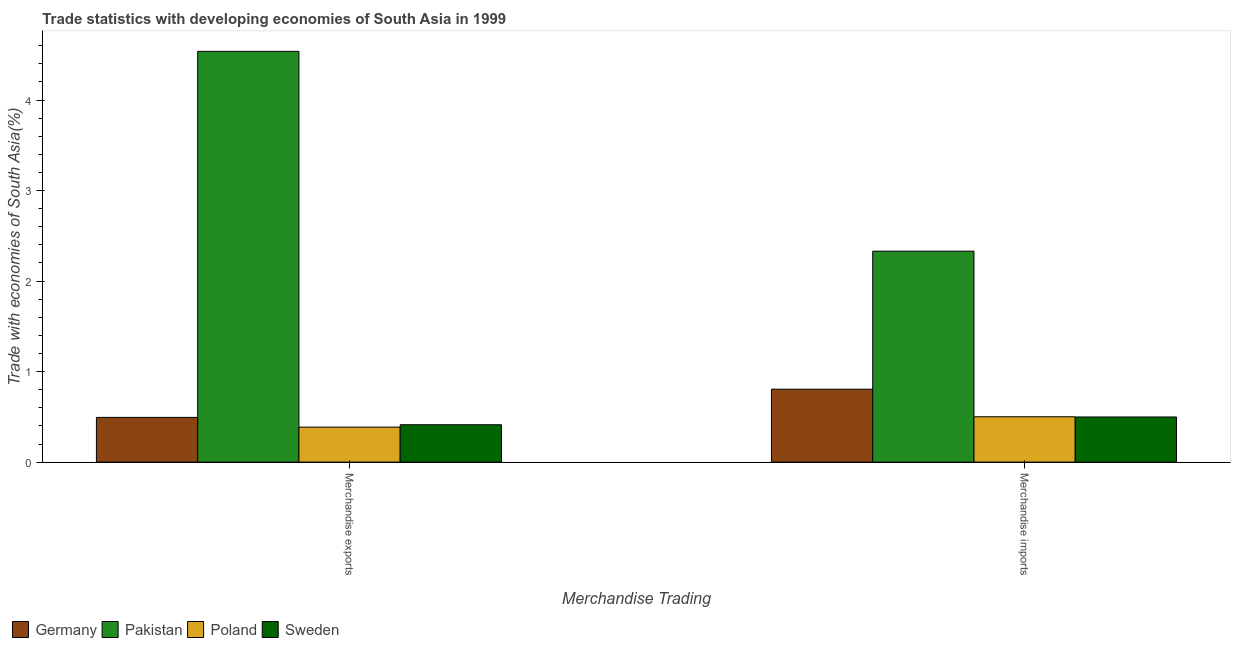How many different coloured bars are there?
Give a very brief answer. 4. Are the number of bars per tick equal to the number of legend labels?
Your response must be concise. Yes. How many bars are there on the 1st tick from the left?
Provide a short and direct response. 4. How many bars are there on the 1st tick from the right?
Keep it short and to the point. 4. What is the merchandise imports in Germany?
Give a very brief answer. 0.81. Across all countries, what is the maximum merchandise imports?
Your answer should be very brief. 2.33. Across all countries, what is the minimum merchandise imports?
Your answer should be very brief. 0.5. What is the total merchandise exports in the graph?
Your response must be concise. 5.83. What is the difference between the merchandise imports in Sweden and that in Germany?
Give a very brief answer. -0.31. What is the difference between the merchandise imports in Poland and the merchandise exports in Germany?
Offer a very short reply. 0.01. What is the average merchandise exports per country?
Give a very brief answer. 1.46. What is the difference between the merchandise exports and merchandise imports in Germany?
Provide a short and direct response. -0.31. In how many countries, is the merchandise imports greater than 0.8 %?
Keep it short and to the point. 2. What is the ratio of the merchandise exports in Pakistan to that in Germany?
Your response must be concise. 9.18. In how many countries, is the merchandise exports greater than the average merchandise exports taken over all countries?
Keep it short and to the point. 1. What does the 2nd bar from the right in Merchandise imports represents?
Your answer should be very brief. Poland. What is the difference between two consecutive major ticks on the Y-axis?
Make the answer very short. 1. Are the values on the major ticks of Y-axis written in scientific E-notation?
Provide a short and direct response. No. Does the graph contain any zero values?
Provide a succinct answer. No. Where does the legend appear in the graph?
Offer a very short reply. Bottom left. How many legend labels are there?
Offer a terse response. 4. How are the legend labels stacked?
Ensure brevity in your answer.  Horizontal. What is the title of the graph?
Provide a short and direct response. Trade statistics with developing economies of South Asia in 1999. What is the label or title of the X-axis?
Offer a terse response. Merchandise Trading. What is the label or title of the Y-axis?
Ensure brevity in your answer.  Trade with economies of South Asia(%). What is the Trade with economies of South Asia(%) of Germany in Merchandise exports?
Provide a succinct answer. 0.49. What is the Trade with economies of South Asia(%) of Pakistan in Merchandise exports?
Offer a terse response. 4.54. What is the Trade with economies of South Asia(%) of Poland in Merchandise exports?
Your answer should be compact. 0.39. What is the Trade with economies of South Asia(%) of Sweden in Merchandise exports?
Your response must be concise. 0.41. What is the Trade with economies of South Asia(%) of Germany in Merchandise imports?
Your answer should be compact. 0.81. What is the Trade with economies of South Asia(%) of Pakistan in Merchandise imports?
Give a very brief answer. 2.33. What is the Trade with economies of South Asia(%) of Poland in Merchandise imports?
Your answer should be very brief. 0.5. What is the Trade with economies of South Asia(%) in Sweden in Merchandise imports?
Your answer should be very brief. 0.5. Across all Merchandise Trading, what is the maximum Trade with economies of South Asia(%) of Germany?
Give a very brief answer. 0.81. Across all Merchandise Trading, what is the maximum Trade with economies of South Asia(%) of Pakistan?
Offer a terse response. 4.54. Across all Merchandise Trading, what is the maximum Trade with economies of South Asia(%) of Poland?
Offer a very short reply. 0.5. Across all Merchandise Trading, what is the maximum Trade with economies of South Asia(%) of Sweden?
Keep it short and to the point. 0.5. Across all Merchandise Trading, what is the minimum Trade with economies of South Asia(%) in Germany?
Offer a terse response. 0.49. Across all Merchandise Trading, what is the minimum Trade with economies of South Asia(%) in Pakistan?
Give a very brief answer. 2.33. Across all Merchandise Trading, what is the minimum Trade with economies of South Asia(%) of Poland?
Your answer should be compact. 0.39. Across all Merchandise Trading, what is the minimum Trade with economies of South Asia(%) of Sweden?
Your response must be concise. 0.41. What is the total Trade with economies of South Asia(%) in Germany in the graph?
Provide a short and direct response. 1.3. What is the total Trade with economies of South Asia(%) in Pakistan in the graph?
Offer a very short reply. 6.87. What is the total Trade with economies of South Asia(%) in Poland in the graph?
Keep it short and to the point. 0.89. What is the total Trade with economies of South Asia(%) of Sweden in the graph?
Make the answer very short. 0.91. What is the difference between the Trade with economies of South Asia(%) in Germany in Merchandise exports and that in Merchandise imports?
Offer a very short reply. -0.31. What is the difference between the Trade with economies of South Asia(%) in Pakistan in Merchandise exports and that in Merchandise imports?
Your response must be concise. 2.21. What is the difference between the Trade with economies of South Asia(%) of Poland in Merchandise exports and that in Merchandise imports?
Your response must be concise. -0.11. What is the difference between the Trade with economies of South Asia(%) of Sweden in Merchandise exports and that in Merchandise imports?
Make the answer very short. -0.09. What is the difference between the Trade with economies of South Asia(%) in Germany in Merchandise exports and the Trade with economies of South Asia(%) in Pakistan in Merchandise imports?
Provide a short and direct response. -1.84. What is the difference between the Trade with economies of South Asia(%) in Germany in Merchandise exports and the Trade with economies of South Asia(%) in Poland in Merchandise imports?
Your answer should be very brief. -0.01. What is the difference between the Trade with economies of South Asia(%) of Germany in Merchandise exports and the Trade with economies of South Asia(%) of Sweden in Merchandise imports?
Your answer should be compact. -0. What is the difference between the Trade with economies of South Asia(%) of Pakistan in Merchandise exports and the Trade with economies of South Asia(%) of Poland in Merchandise imports?
Provide a succinct answer. 4.04. What is the difference between the Trade with economies of South Asia(%) of Pakistan in Merchandise exports and the Trade with economies of South Asia(%) of Sweden in Merchandise imports?
Make the answer very short. 4.04. What is the difference between the Trade with economies of South Asia(%) of Poland in Merchandise exports and the Trade with economies of South Asia(%) of Sweden in Merchandise imports?
Offer a very short reply. -0.11. What is the average Trade with economies of South Asia(%) of Germany per Merchandise Trading?
Your answer should be compact. 0.65. What is the average Trade with economies of South Asia(%) of Pakistan per Merchandise Trading?
Your answer should be compact. 3.43. What is the average Trade with economies of South Asia(%) in Poland per Merchandise Trading?
Ensure brevity in your answer.  0.44. What is the average Trade with economies of South Asia(%) in Sweden per Merchandise Trading?
Ensure brevity in your answer.  0.46. What is the difference between the Trade with economies of South Asia(%) of Germany and Trade with economies of South Asia(%) of Pakistan in Merchandise exports?
Provide a short and direct response. -4.04. What is the difference between the Trade with economies of South Asia(%) in Germany and Trade with economies of South Asia(%) in Poland in Merchandise exports?
Keep it short and to the point. 0.11. What is the difference between the Trade with economies of South Asia(%) of Germany and Trade with economies of South Asia(%) of Sweden in Merchandise exports?
Your answer should be very brief. 0.08. What is the difference between the Trade with economies of South Asia(%) in Pakistan and Trade with economies of South Asia(%) in Poland in Merchandise exports?
Offer a very short reply. 4.15. What is the difference between the Trade with economies of South Asia(%) in Pakistan and Trade with economies of South Asia(%) in Sweden in Merchandise exports?
Provide a short and direct response. 4.12. What is the difference between the Trade with economies of South Asia(%) of Poland and Trade with economies of South Asia(%) of Sweden in Merchandise exports?
Offer a terse response. -0.03. What is the difference between the Trade with economies of South Asia(%) of Germany and Trade with economies of South Asia(%) of Pakistan in Merchandise imports?
Give a very brief answer. -1.52. What is the difference between the Trade with economies of South Asia(%) in Germany and Trade with economies of South Asia(%) in Poland in Merchandise imports?
Your response must be concise. 0.3. What is the difference between the Trade with economies of South Asia(%) in Germany and Trade with economies of South Asia(%) in Sweden in Merchandise imports?
Provide a short and direct response. 0.31. What is the difference between the Trade with economies of South Asia(%) in Pakistan and Trade with economies of South Asia(%) in Poland in Merchandise imports?
Ensure brevity in your answer.  1.83. What is the difference between the Trade with economies of South Asia(%) of Pakistan and Trade with economies of South Asia(%) of Sweden in Merchandise imports?
Ensure brevity in your answer.  1.83. What is the difference between the Trade with economies of South Asia(%) of Poland and Trade with economies of South Asia(%) of Sweden in Merchandise imports?
Ensure brevity in your answer.  0. What is the ratio of the Trade with economies of South Asia(%) of Germany in Merchandise exports to that in Merchandise imports?
Your answer should be compact. 0.61. What is the ratio of the Trade with economies of South Asia(%) of Pakistan in Merchandise exports to that in Merchandise imports?
Keep it short and to the point. 1.95. What is the ratio of the Trade with economies of South Asia(%) of Poland in Merchandise exports to that in Merchandise imports?
Provide a short and direct response. 0.77. What is the ratio of the Trade with economies of South Asia(%) in Sweden in Merchandise exports to that in Merchandise imports?
Your answer should be very brief. 0.83. What is the difference between the highest and the second highest Trade with economies of South Asia(%) of Germany?
Your response must be concise. 0.31. What is the difference between the highest and the second highest Trade with economies of South Asia(%) of Pakistan?
Provide a succinct answer. 2.21. What is the difference between the highest and the second highest Trade with economies of South Asia(%) of Poland?
Your answer should be very brief. 0.11. What is the difference between the highest and the second highest Trade with economies of South Asia(%) of Sweden?
Keep it short and to the point. 0.09. What is the difference between the highest and the lowest Trade with economies of South Asia(%) in Germany?
Provide a succinct answer. 0.31. What is the difference between the highest and the lowest Trade with economies of South Asia(%) of Pakistan?
Ensure brevity in your answer.  2.21. What is the difference between the highest and the lowest Trade with economies of South Asia(%) of Poland?
Offer a terse response. 0.11. What is the difference between the highest and the lowest Trade with economies of South Asia(%) in Sweden?
Your answer should be very brief. 0.09. 